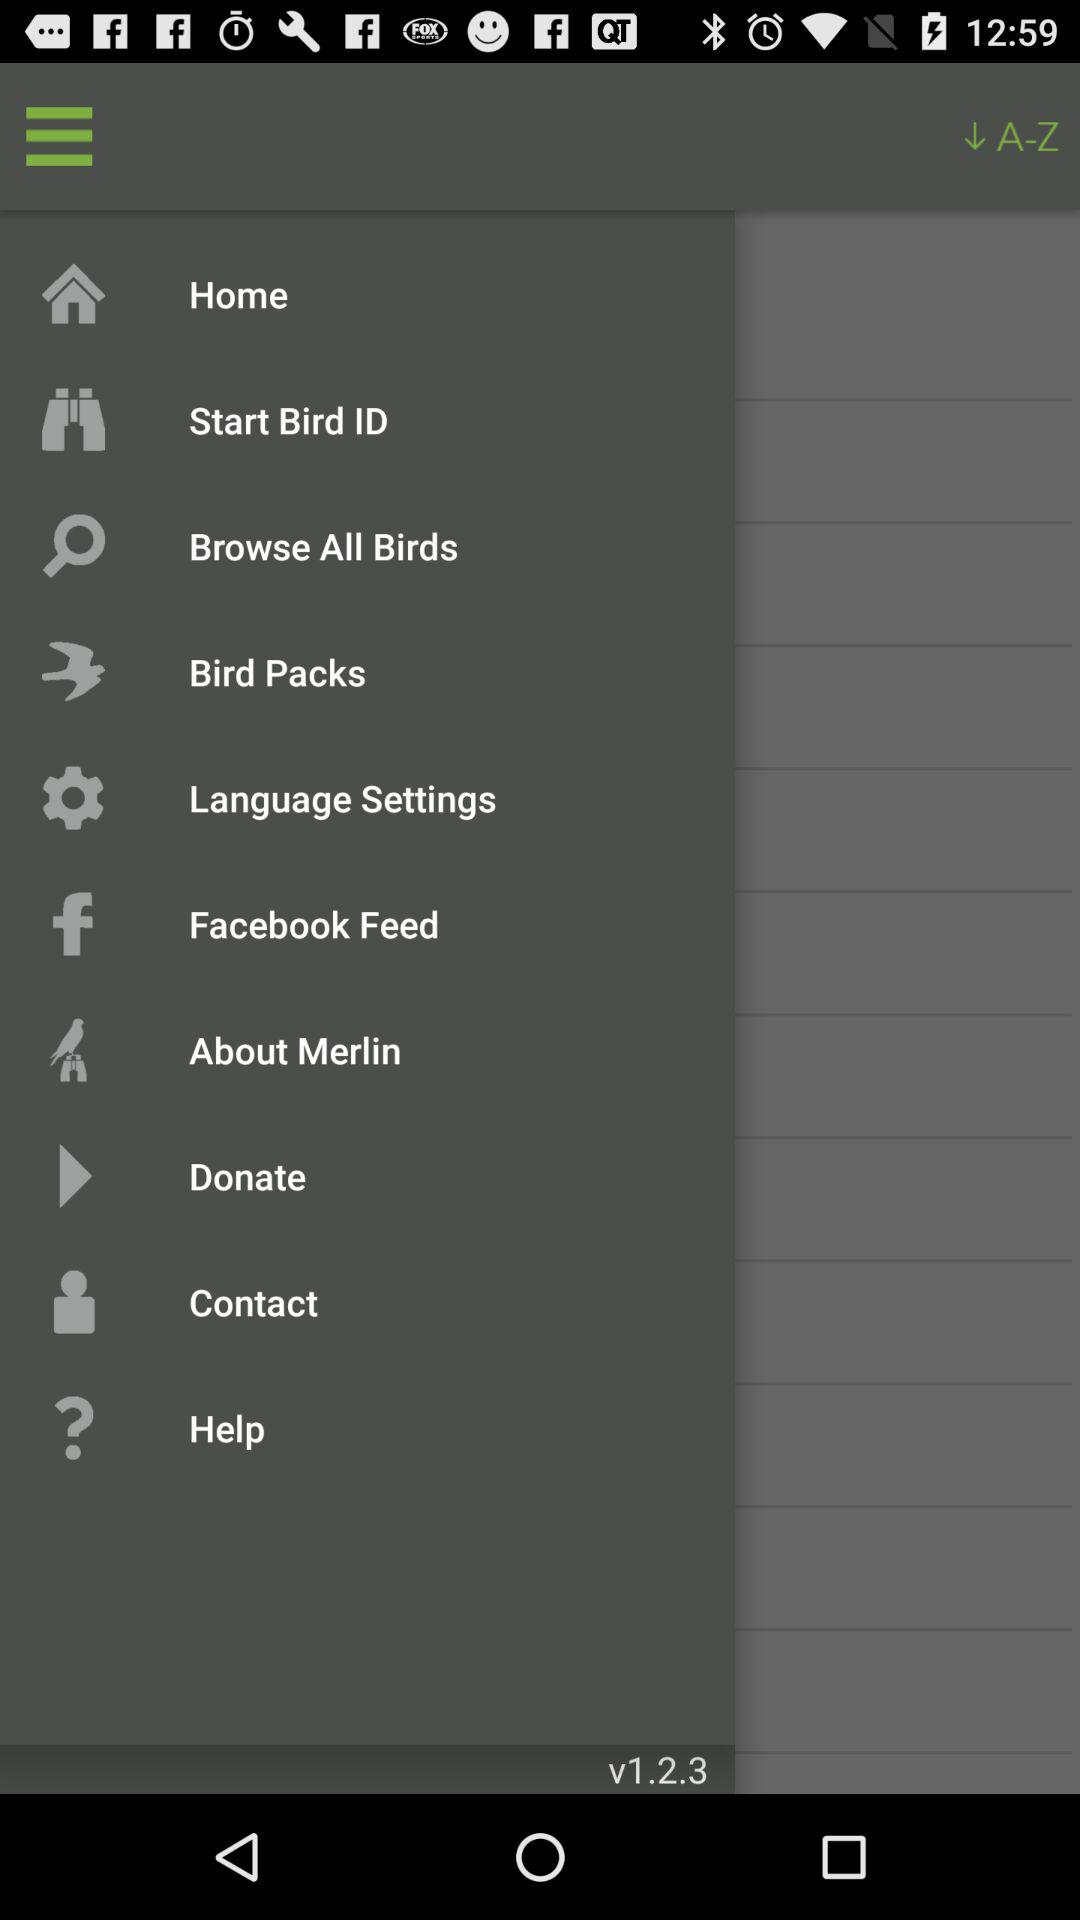What is the current version? The current version is v1.2.3. 